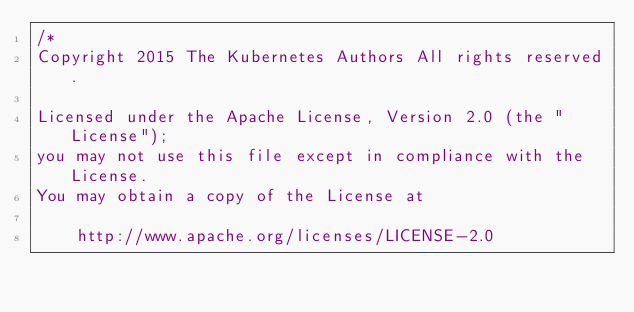Convert code to text. <code><loc_0><loc_0><loc_500><loc_500><_Go_>/*
Copyright 2015 The Kubernetes Authors All rights reserved.

Licensed under the Apache License, Version 2.0 (the "License");
you may not use this file except in compliance with the License.
You may obtain a copy of the License at

    http://www.apache.org/licenses/LICENSE-2.0
</code> 